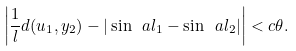Convert formula to latex. <formula><loc_0><loc_0><loc_500><loc_500>\left | \frac { 1 } { l } d ( u _ { 1 } , y _ { 2 } ) - | \sin \ a l _ { 1 } - \sin \ a l _ { 2 } | \right | < c \theta .</formula> 